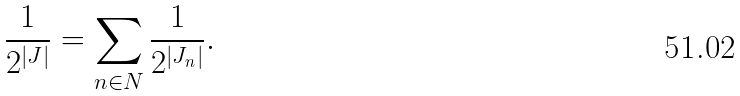<formula> <loc_0><loc_0><loc_500><loc_500>\frac { 1 } { 2 ^ { | J | } } = \sum _ { n \in N } \frac { 1 } { 2 ^ { | J _ { n } | } } .</formula> 